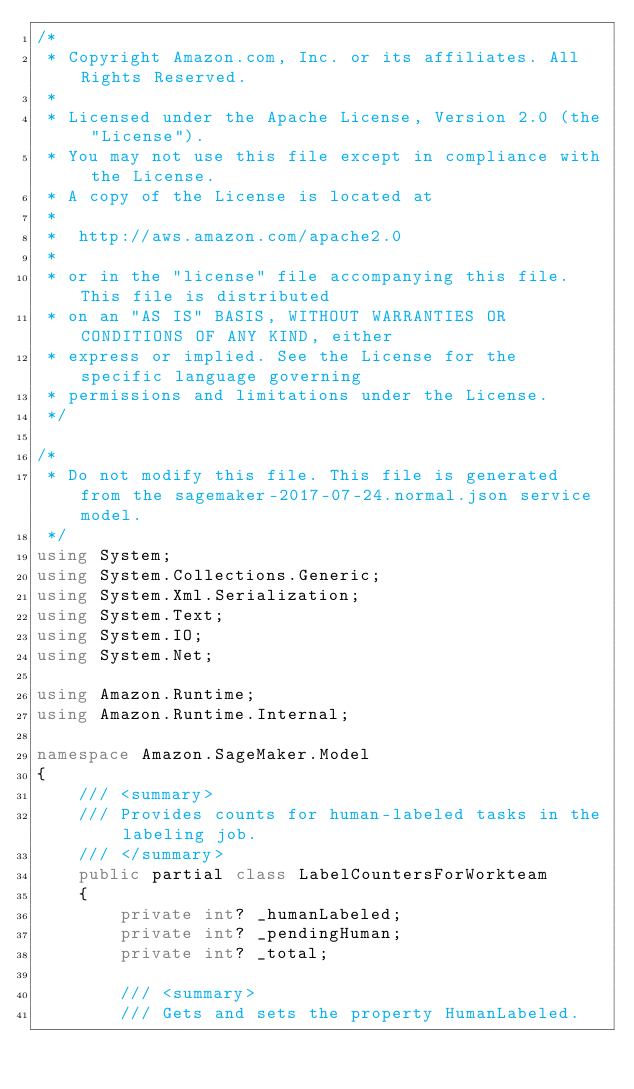<code> <loc_0><loc_0><loc_500><loc_500><_C#_>/*
 * Copyright Amazon.com, Inc. or its affiliates. All Rights Reserved.
 * 
 * Licensed under the Apache License, Version 2.0 (the "License").
 * You may not use this file except in compliance with the License.
 * A copy of the License is located at
 * 
 *  http://aws.amazon.com/apache2.0
 * 
 * or in the "license" file accompanying this file. This file is distributed
 * on an "AS IS" BASIS, WITHOUT WARRANTIES OR CONDITIONS OF ANY KIND, either
 * express or implied. See the License for the specific language governing
 * permissions and limitations under the License.
 */

/*
 * Do not modify this file. This file is generated from the sagemaker-2017-07-24.normal.json service model.
 */
using System;
using System.Collections.Generic;
using System.Xml.Serialization;
using System.Text;
using System.IO;
using System.Net;

using Amazon.Runtime;
using Amazon.Runtime.Internal;

namespace Amazon.SageMaker.Model
{
    /// <summary>
    /// Provides counts for human-labeled tasks in the labeling job.
    /// </summary>
    public partial class LabelCountersForWorkteam
    {
        private int? _humanLabeled;
        private int? _pendingHuman;
        private int? _total;

        /// <summary>
        /// Gets and sets the property HumanLabeled. </code> 